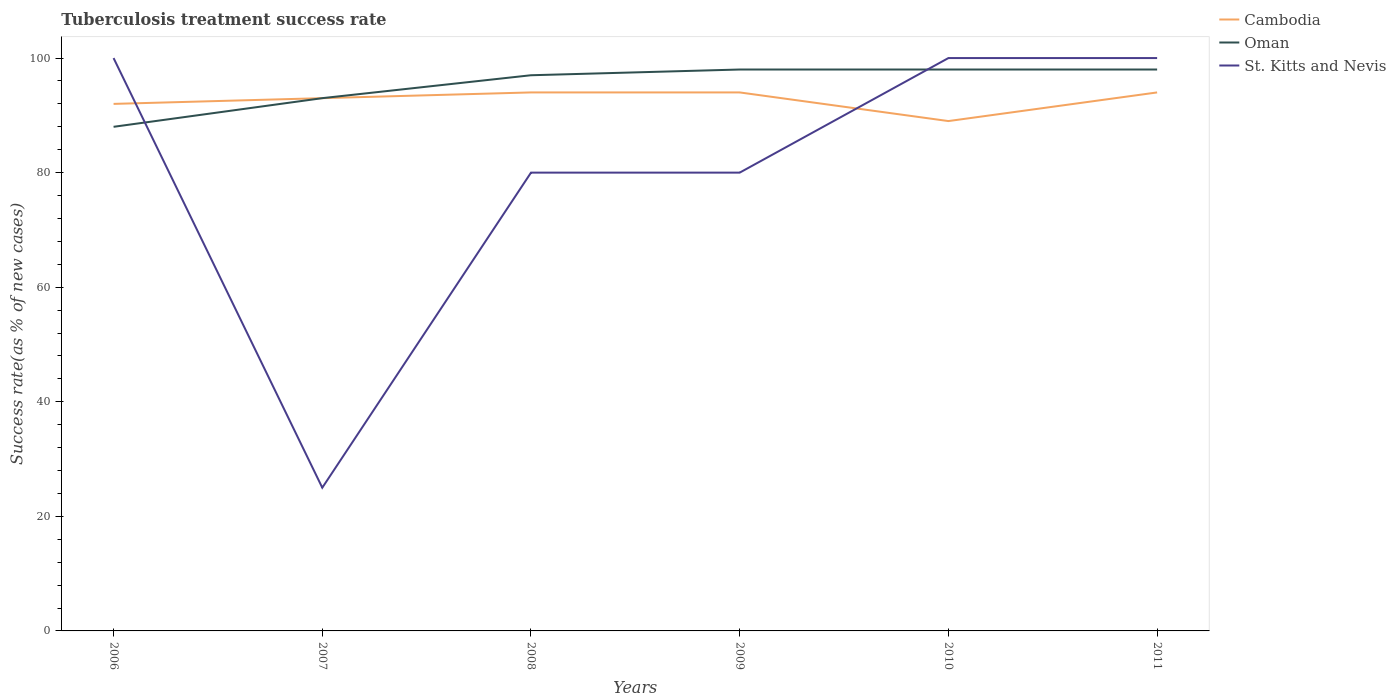How many different coloured lines are there?
Offer a terse response. 3. Does the line corresponding to Cambodia intersect with the line corresponding to Oman?
Provide a succinct answer. Yes. In which year was the tuberculosis treatment success rate in Cambodia maximum?
Offer a terse response. 2010. What is the total tuberculosis treatment success rate in Cambodia in the graph?
Offer a very short reply. 3. What is the difference between the highest and the second highest tuberculosis treatment success rate in Cambodia?
Your answer should be very brief. 5. How many lines are there?
Keep it short and to the point. 3. How many years are there in the graph?
Your response must be concise. 6. Are the values on the major ticks of Y-axis written in scientific E-notation?
Your answer should be very brief. No. Where does the legend appear in the graph?
Provide a succinct answer. Top right. How many legend labels are there?
Give a very brief answer. 3. What is the title of the graph?
Offer a terse response. Tuberculosis treatment success rate. What is the label or title of the Y-axis?
Offer a terse response. Success rate(as % of new cases). What is the Success rate(as % of new cases) of Cambodia in 2006?
Keep it short and to the point. 92. What is the Success rate(as % of new cases) of Oman in 2006?
Keep it short and to the point. 88. What is the Success rate(as % of new cases) of Cambodia in 2007?
Provide a succinct answer. 93. What is the Success rate(as % of new cases) in Oman in 2007?
Offer a terse response. 93. What is the Success rate(as % of new cases) in Cambodia in 2008?
Offer a very short reply. 94. What is the Success rate(as % of new cases) in Oman in 2008?
Provide a succinct answer. 97. What is the Success rate(as % of new cases) in St. Kitts and Nevis in 2008?
Give a very brief answer. 80. What is the Success rate(as % of new cases) in Cambodia in 2009?
Provide a succinct answer. 94. What is the Success rate(as % of new cases) in Oman in 2009?
Offer a terse response. 98. What is the Success rate(as % of new cases) of St. Kitts and Nevis in 2009?
Provide a succinct answer. 80. What is the Success rate(as % of new cases) in Cambodia in 2010?
Keep it short and to the point. 89. What is the Success rate(as % of new cases) in St. Kitts and Nevis in 2010?
Ensure brevity in your answer.  100. What is the Success rate(as % of new cases) of Cambodia in 2011?
Ensure brevity in your answer.  94. What is the Success rate(as % of new cases) of Oman in 2011?
Offer a very short reply. 98. What is the Success rate(as % of new cases) of St. Kitts and Nevis in 2011?
Your answer should be very brief. 100. Across all years, what is the maximum Success rate(as % of new cases) in Cambodia?
Give a very brief answer. 94. Across all years, what is the maximum Success rate(as % of new cases) of St. Kitts and Nevis?
Your answer should be very brief. 100. Across all years, what is the minimum Success rate(as % of new cases) of Cambodia?
Your answer should be compact. 89. Across all years, what is the minimum Success rate(as % of new cases) in Oman?
Offer a terse response. 88. What is the total Success rate(as % of new cases) of Cambodia in the graph?
Give a very brief answer. 556. What is the total Success rate(as % of new cases) in Oman in the graph?
Give a very brief answer. 572. What is the total Success rate(as % of new cases) in St. Kitts and Nevis in the graph?
Make the answer very short. 485. What is the difference between the Success rate(as % of new cases) in Oman in 2006 and that in 2008?
Your answer should be compact. -9. What is the difference between the Success rate(as % of new cases) of St. Kitts and Nevis in 2006 and that in 2008?
Give a very brief answer. 20. What is the difference between the Success rate(as % of new cases) of Cambodia in 2006 and that in 2009?
Give a very brief answer. -2. What is the difference between the Success rate(as % of new cases) of St. Kitts and Nevis in 2006 and that in 2011?
Offer a very short reply. 0. What is the difference between the Success rate(as % of new cases) of St. Kitts and Nevis in 2007 and that in 2008?
Provide a short and direct response. -55. What is the difference between the Success rate(as % of new cases) of Cambodia in 2007 and that in 2009?
Make the answer very short. -1. What is the difference between the Success rate(as % of new cases) in St. Kitts and Nevis in 2007 and that in 2009?
Give a very brief answer. -55. What is the difference between the Success rate(as % of new cases) in Cambodia in 2007 and that in 2010?
Your answer should be very brief. 4. What is the difference between the Success rate(as % of new cases) in St. Kitts and Nevis in 2007 and that in 2010?
Provide a short and direct response. -75. What is the difference between the Success rate(as % of new cases) in Oman in 2007 and that in 2011?
Ensure brevity in your answer.  -5. What is the difference between the Success rate(as % of new cases) of St. Kitts and Nevis in 2007 and that in 2011?
Your answer should be compact. -75. What is the difference between the Success rate(as % of new cases) in Cambodia in 2008 and that in 2009?
Provide a short and direct response. 0. What is the difference between the Success rate(as % of new cases) of Oman in 2008 and that in 2010?
Ensure brevity in your answer.  -1. What is the difference between the Success rate(as % of new cases) in St. Kitts and Nevis in 2008 and that in 2010?
Ensure brevity in your answer.  -20. What is the difference between the Success rate(as % of new cases) in Oman in 2008 and that in 2011?
Provide a short and direct response. -1. What is the difference between the Success rate(as % of new cases) of St. Kitts and Nevis in 2008 and that in 2011?
Keep it short and to the point. -20. What is the difference between the Success rate(as % of new cases) in Oman in 2009 and that in 2010?
Make the answer very short. 0. What is the difference between the Success rate(as % of new cases) in Cambodia in 2009 and that in 2011?
Offer a very short reply. 0. What is the difference between the Success rate(as % of new cases) in Oman in 2009 and that in 2011?
Make the answer very short. 0. What is the difference between the Success rate(as % of new cases) in St. Kitts and Nevis in 2009 and that in 2011?
Provide a succinct answer. -20. What is the difference between the Success rate(as % of new cases) in Oman in 2010 and that in 2011?
Ensure brevity in your answer.  0. What is the difference between the Success rate(as % of new cases) in Cambodia in 2006 and the Success rate(as % of new cases) in Oman in 2007?
Ensure brevity in your answer.  -1. What is the difference between the Success rate(as % of new cases) of Cambodia in 2006 and the Success rate(as % of new cases) of St. Kitts and Nevis in 2007?
Ensure brevity in your answer.  67. What is the difference between the Success rate(as % of new cases) of Cambodia in 2006 and the Success rate(as % of new cases) of Oman in 2008?
Make the answer very short. -5. What is the difference between the Success rate(as % of new cases) of Oman in 2006 and the Success rate(as % of new cases) of St. Kitts and Nevis in 2008?
Offer a terse response. 8. What is the difference between the Success rate(as % of new cases) of Cambodia in 2006 and the Success rate(as % of new cases) of St. Kitts and Nevis in 2009?
Provide a short and direct response. 12. What is the difference between the Success rate(as % of new cases) in Oman in 2006 and the Success rate(as % of new cases) in St. Kitts and Nevis in 2009?
Provide a short and direct response. 8. What is the difference between the Success rate(as % of new cases) in Oman in 2006 and the Success rate(as % of new cases) in St. Kitts and Nevis in 2010?
Make the answer very short. -12. What is the difference between the Success rate(as % of new cases) of Cambodia in 2006 and the Success rate(as % of new cases) of Oman in 2011?
Ensure brevity in your answer.  -6. What is the difference between the Success rate(as % of new cases) of Cambodia in 2006 and the Success rate(as % of new cases) of St. Kitts and Nevis in 2011?
Your answer should be very brief. -8. What is the difference between the Success rate(as % of new cases) of Oman in 2006 and the Success rate(as % of new cases) of St. Kitts and Nevis in 2011?
Provide a succinct answer. -12. What is the difference between the Success rate(as % of new cases) of Cambodia in 2007 and the Success rate(as % of new cases) of Oman in 2008?
Offer a very short reply. -4. What is the difference between the Success rate(as % of new cases) of Cambodia in 2007 and the Success rate(as % of new cases) of Oman in 2009?
Offer a terse response. -5. What is the difference between the Success rate(as % of new cases) of Oman in 2007 and the Success rate(as % of new cases) of St. Kitts and Nevis in 2009?
Give a very brief answer. 13. What is the difference between the Success rate(as % of new cases) in Cambodia in 2007 and the Success rate(as % of new cases) in St. Kitts and Nevis in 2010?
Offer a terse response. -7. What is the difference between the Success rate(as % of new cases) of Cambodia in 2007 and the Success rate(as % of new cases) of Oman in 2011?
Keep it short and to the point. -5. What is the difference between the Success rate(as % of new cases) in Cambodia in 2007 and the Success rate(as % of new cases) in St. Kitts and Nevis in 2011?
Your answer should be compact. -7. What is the difference between the Success rate(as % of new cases) in Oman in 2007 and the Success rate(as % of new cases) in St. Kitts and Nevis in 2011?
Offer a very short reply. -7. What is the difference between the Success rate(as % of new cases) in Cambodia in 2008 and the Success rate(as % of new cases) in Oman in 2009?
Keep it short and to the point. -4. What is the difference between the Success rate(as % of new cases) in Cambodia in 2008 and the Success rate(as % of new cases) in St. Kitts and Nevis in 2009?
Ensure brevity in your answer.  14. What is the difference between the Success rate(as % of new cases) of Oman in 2008 and the Success rate(as % of new cases) of St. Kitts and Nevis in 2009?
Offer a very short reply. 17. What is the difference between the Success rate(as % of new cases) of Cambodia in 2008 and the Success rate(as % of new cases) of Oman in 2010?
Keep it short and to the point. -4. What is the difference between the Success rate(as % of new cases) of Oman in 2008 and the Success rate(as % of new cases) of St. Kitts and Nevis in 2010?
Provide a succinct answer. -3. What is the difference between the Success rate(as % of new cases) of Cambodia in 2008 and the Success rate(as % of new cases) of St. Kitts and Nevis in 2011?
Make the answer very short. -6. What is the difference between the Success rate(as % of new cases) in Cambodia in 2009 and the Success rate(as % of new cases) in St. Kitts and Nevis in 2010?
Ensure brevity in your answer.  -6. What is the difference between the Success rate(as % of new cases) of Oman in 2009 and the Success rate(as % of new cases) of St. Kitts and Nevis in 2010?
Make the answer very short. -2. What is the difference between the Success rate(as % of new cases) in Cambodia in 2009 and the Success rate(as % of new cases) in St. Kitts and Nevis in 2011?
Offer a very short reply. -6. What is the difference between the Success rate(as % of new cases) in Cambodia in 2010 and the Success rate(as % of new cases) in Oman in 2011?
Make the answer very short. -9. What is the average Success rate(as % of new cases) of Cambodia per year?
Your answer should be compact. 92.67. What is the average Success rate(as % of new cases) in Oman per year?
Keep it short and to the point. 95.33. What is the average Success rate(as % of new cases) in St. Kitts and Nevis per year?
Give a very brief answer. 80.83. In the year 2006, what is the difference between the Success rate(as % of new cases) in Cambodia and Success rate(as % of new cases) in St. Kitts and Nevis?
Provide a short and direct response. -8. In the year 2007, what is the difference between the Success rate(as % of new cases) in Cambodia and Success rate(as % of new cases) in Oman?
Keep it short and to the point. 0. In the year 2007, what is the difference between the Success rate(as % of new cases) in Cambodia and Success rate(as % of new cases) in St. Kitts and Nevis?
Your answer should be compact. 68. In the year 2007, what is the difference between the Success rate(as % of new cases) of Oman and Success rate(as % of new cases) of St. Kitts and Nevis?
Keep it short and to the point. 68. In the year 2008, what is the difference between the Success rate(as % of new cases) in Cambodia and Success rate(as % of new cases) in Oman?
Your answer should be compact. -3. In the year 2009, what is the difference between the Success rate(as % of new cases) in Oman and Success rate(as % of new cases) in St. Kitts and Nevis?
Make the answer very short. 18. In the year 2010, what is the difference between the Success rate(as % of new cases) of Cambodia and Success rate(as % of new cases) of St. Kitts and Nevis?
Your answer should be compact. -11. In the year 2010, what is the difference between the Success rate(as % of new cases) of Oman and Success rate(as % of new cases) of St. Kitts and Nevis?
Offer a very short reply. -2. What is the ratio of the Success rate(as % of new cases) of Oman in 2006 to that in 2007?
Offer a very short reply. 0.95. What is the ratio of the Success rate(as % of new cases) in St. Kitts and Nevis in 2006 to that in 2007?
Give a very brief answer. 4. What is the ratio of the Success rate(as % of new cases) in Cambodia in 2006 to that in 2008?
Your response must be concise. 0.98. What is the ratio of the Success rate(as % of new cases) in Oman in 2006 to that in 2008?
Your answer should be compact. 0.91. What is the ratio of the Success rate(as % of new cases) of St. Kitts and Nevis in 2006 to that in 2008?
Your answer should be compact. 1.25. What is the ratio of the Success rate(as % of new cases) in Cambodia in 2006 to that in 2009?
Keep it short and to the point. 0.98. What is the ratio of the Success rate(as % of new cases) of Oman in 2006 to that in 2009?
Give a very brief answer. 0.9. What is the ratio of the Success rate(as % of new cases) of Cambodia in 2006 to that in 2010?
Offer a terse response. 1.03. What is the ratio of the Success rate(as % of new cases) of Oman in 2006 to that in 2010?
Offer a terse response. 0.9. What is the ratio of the Success rate(as % of new cases) of Cambodia in 2006 to that in 2011?
Provide a short and direct response. 0.98. What is the ratio of the Success rate(as % of new cases) of Oman in 2006 to that in 2011?
Your response must be concise. 0.9. What is the ratio of the Success rate(as % of new cases) of St. Kitts and Nevis in 2006 to that in 2011?
Your answer should be very brief. 1. What is the ratio of the Success rate(as % of new cases) of Oman in 2007 to that in 2008?
Give a very brief answer. 0.96. What is the ratio of the Success rate(as % of new cases) in St. Kitts and Nevis in 2007 to that in 2008?
Ensure brevity in your answer.  0.31. What is the ratio of the Success rate(as % of new cases) in Cambodia in 2007 to that in 2009?
Your answer should be very brief. 0.99. What is the ratio of the Success rate(as % of new cases) of Oman in 2007 to that in 2009?
Offer a very short reply. 0.95. What is the ratio of the Success rate(as % of new cases) in St. Kitts and Nevis in 2007 to that in 2009?
Give a very brief answer. 0.31. What is the ratio of the Success rate(as % of new cases) in Cambodia in 2007 to that in 2010?
Ensure brevity in your answer.  1.04. What is the ratio of the Success rate(as % of new cases) of Oman in 2007 to that in 2010?
Provide a short and direct response. 0.95. What is the ratio of the Success rate(as % of new cases) of Oman in 2007 to that in 2011?
Offer a terse response. 0.95. What is the ratio of the Success rate(as % of new cases) in Oman in 2008 to that in 2009?
Provide a short and direct response. 0.99. What is the ratio of the Success rate(as % of new cases) in Cambodia in 2008 to that in 2010?
Give a very brief answer. 1.06. What is the ratio of the Success rate(as % of new cases) of Oman in 2008 to that in 2010?
Offer a very short reply. 0.99. What is the ratio of the Success rate(as % of new cases) of Cambodia in 2008 to that in 2011?
Offer a terse response. 1. What is the ratio of the Success rate(as % of new cases) of St. Kitts and Nevis in 2008 to that in 2011?
Make the answer very short. 0.8. What is the ratio of the Success rate(as % of new cases) of Cambodia in 2009 to that in 2010?
Make the answer very short. 1.06. What is the ratio of the Success rate(as % of new cases) of St. Kitts and Nevis in 2009 to that in 2010?
Your answer should be very brief. 0.8. What is the ratio of the Success rate(as % of new cases) in Oman in 2009 to that in 2011?
Your answer should be compact. 1. What is the ratio of the Success rate(as % of new cases) in Cambodia in 2010 to that in 2011?
Give a very brief answer. 0.95. What is the ratio of the Success rate(as % of new cases) of Oman in 2010 to that in 2011?
Your response must be concise. 1. What is the difference between the highest and the second highest Success rate(as % of new cases) in St. Kitts and Nevis?
Make the answer very short. 0. What is the difference between the highest and the lowest Success rate(as % of new cases) in St. Kitts and Nevis?
Give a very brief answer. 75. 